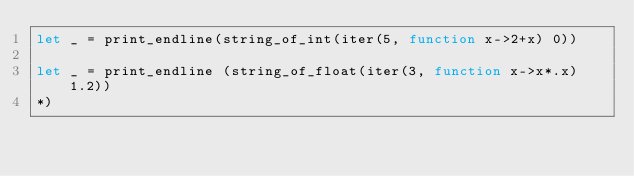Convert code to text. <code><loc_0><loc_0><loc_500><loc_500><_OCaml_>let _ = print_endline(string_of_int(iter(5, function x->2+x) 0))

let _ = print_endline (string_of_float(iter(3, function x->x*.x) 1.2))
*)
</code> 